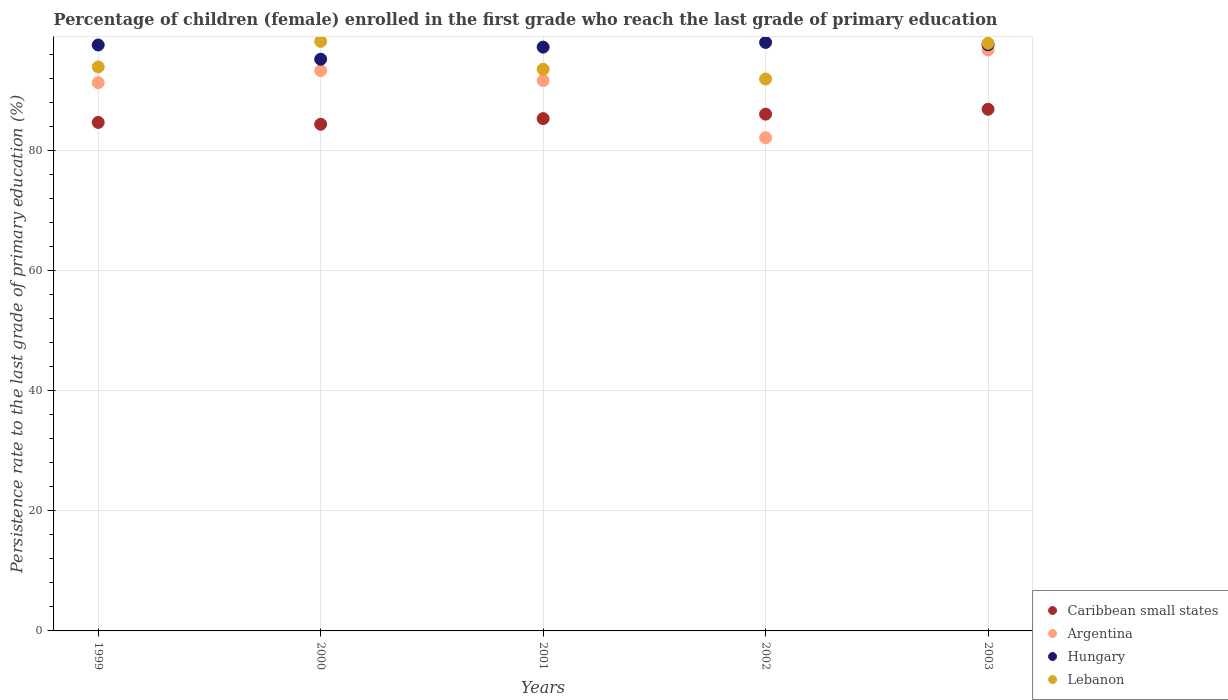Is the number of dotlines equal to the number of legend labels?
Your answer should be compact. Yes. What is the persistence rate of children in Hungary in 2003?
Your answer should be compact. 97.58. Across all years, what is the maximum persistence rate of children in Lebanon?
Your response must be concise. 98.15. Across all years, what is the minimum persistence rate of children in Lebanon?
Make the answer very short. 91.89. In which year was the persistence rate of children in Caribbean small states maximum?
Make the answer very short. 2003. In which year was the persistence rate of children in Caribbean small states minimum?
Give a very brief answer. 2000. What is the total persistence rate of children in Argentina in the graph?
Provide a succinct answer. 455.02. What is the difference between the persistence rate of children in Caribbean small states in 1999 and that in 2000?
Your answer should be compact. 0.3. What is the difference between the persistence rate of children in Argentina in 2002 and the persistence rate of children in Lebanon in 1999?
Provide a short and direct response. -11.79. What is the average persistence rate of children in Argentina per year?
Your response must be concise. 91. In the year 2002, what is the difference between the persistence rate of children in Caribbean small states and persistence rate of children in Hungary?
Ensure brevity in your answer.  -11.94. In how many years, is the persistence rate of children in Argentina greater than 16 %?
Your answer should be compact. 5. What is the ratio of the persistence rate of children in Caribbean small states in 1999 to that in 2002?
Ensure brevity in your answer.  0.98. Is the difference between the persistence rate of children in Caribbean small states in 1999 and 2001 greater than the difference between the persistence rate of children in Hungary in 1999 and 2001?
Give a very brief answer. No. What is the difference between the highest and the second highest persistence rate of children in Argentina?
Your response must be concise. 3.44. What is the difference between the highest and the lowest persistence rate of children in Hungary?
Your answer should be compact. 2.8. Is it the case that in every year, the sum of the persistence rate of children in Caribbean small states and persistence rate of children in Hungary  is greater than the sum of persistence rate of children in Lebanon and persistence rate of children in Argentina?
Make the answer very short. No. Is the persistence rate of children in Hungary strictly greater than the persistence rate of children in Caribbean small states over the years?
Your response must be concise. Yes. How many dotlines are there?
Your answer should be compact. 4. How many years are there in the graph?
Your response must be concise. 5. What is the difference between two consecutive major ticks on the Y-axis?
Give a very brief answer. 20. Are the values on the major ticks of Y-axis written in scientific E-notation?
Offer a very short reply. No. Does the graph contain any zero values?
Provide a short and direct response. No. Where does the legend appear in the graph?
Make the answer very short. Bottom right. How many legend labels are there?
Offer a terse response. 4. How are the legend labels stacked?
Give a very brief answer. Vertical. What is the title of the graph?
Your response must be concise. Percentage of children (female) enrolled in the first grade who reach the last grade of primary education. What is the label or title of the Y-axis?
Your answer should be compact. Persistence rate to the last grade of primary education (%). What is the Persistence rate to the last grade of primary education (%) in Caribbean small states in 1999?
Provide a short and direct response. 84.66. What is the Persistence rate to the last grade of primary education (%) in Argentina in 1999?
Ensure brevity in your answer.  91.28. What is the Persistence rate to the last grade of primary education (%) of Hungary in 1999?
Provide a succinct answer. 97.55. What is the Persistence rate to the last grade of primary education (%) of Lebanon in 1999?
Provide a short and direct response. 93.9. What is the Persistence rate to the last grade of primary education (%) in Caribbean small states in 2000?
Give a very brief answer. 84.36. What is the Persistence rate to the last grade of primary education (%) in Argentina in 2000?
Make the answer very short. 93.28. What is the Persistence rate to the last grade of primary education (%) in Hungary in 2000?
Your answer should be very brief. 95.18. What is the Persistence rate to the last grade of primary education (%) of Lebanon in 2000?
Offer a terse response. 98.15. What is the Persistence rate to the last grade of primary education (%) of Caribbean small states in 2001?
Make the answer very short. 85.3. What is the Persistence rate to the last grade of primary education (%) in Argentina in 2001?
Your answer should be compact. 91.63. What is the Persistence rate to the last grade of primary education (%) of Hungary in 2001?
Your response must be concise. 97.19. What is the Persistence rate to the last grade of primary education (%) in Lebanon in 2001?
Keep it short and to the point. 93.51. What is the Persistence rate to the last grade of primary education (%) of Caribbean small states in 2002?
Provide a succinct answer. 86.04. What is the Persistence rate to the last grade of primary education (%) of Argentina in 2002?
Your answer should be very brief. 82.11. What is the Persistence rate to the last grade of primary education (%) of Hungary in 2002?
Offer a very short reply. 97.98. What is the Persistence rate to the last grade of primary education (%) of Lebanon in 2002?
Give a very brief answer. 91.89. What is the Persistence rate to the last grade of primary education (%) in Caribbean small states in 2003?
Your answer should be very brief. 86.85. What is the Persistence rate to the last grade of primary education (%) of Argentina in 2003?
Make the answer very short. 96.72. What is the Persistence rate to the last grade of primary education (%) of Hungary in 2003?
Provide a short and direct response. 97.58. What is the Persistence rate to the last grade of primary education (%) of Lebanon in 2003?
Your response must be concise. 97.84. Across all years, what is the maximum Persistence rate to the last grade of primary education (%) of Caribbean small states?
Give a very brief answer. 86.85. Across all years, what is the maximum Persistence rate to the last grade of primary education (%) in Argentina?
Ensure brevity in your answer.  96.72. Across all years, what is the maximum Persistence rate to the last grade of primary education (%) in Hungary?
Make the answer very short. 97.98. Across all years, what is the maximum Persistence rate to the last grade of primary education (%) in Lebanon?
Offer a terse response. 98.15. Across all years, what is the minimum Persistence rate to the last grade of primary education (%) in Caribbean small states?
Provide a short and direct response. 84.36. Across all years, what is the minimum Persistence rate to the last grade of primary education (%) in Argentina?
Offer a very short reply. 82.11. Across all years, what is the minimum Persistence rate to the last grade of primary education (%) of Hungary?
Provide a short and direct response. 95.18. Across all years, what is the minimum Persistence rate to the last grade of primary education (%) of Lebanon?
Your response must be concise. 91.89. What is the total Persistence rate to the last grade of primary education (%) in Caribbean small states in the graph?
Make the answer very short. 427.2. What is the total Persistence rate to the last grade of primary education (%) of Argentina in the graph?
Keep it short and to the point. 455.02. What is the total Persistence rate to the last grade of primary education (%) in Hungary in the graph?
Your response must be concise. 485.49. What is the total Persistence rate to the last grade of primary education (%) in Lebanon in the graph?
Ensure brevity in your answer.  475.29. What is the difference between the Persistence rate to the last grade of primary education (%) in Caribbean small states in 1999 and that in 2000?
Give a very brief answer. 0.3. What is the difference between the Persistence rate to the last grade of primary education (%) of Argentina in 1999 and that in 2000?
Provide a short and direct response. -2. What is the difference between the Persistence rate to the last grade of primary education (%) of Hungary in 1999 and that in 2000?
Give a very brief answer. 2.37. What is the difference between the Persistence rate to the last grade of primary education (%) of Lebanon in 1999 and that in 2000?
Keep it short and to the point. -4.25. What is the difference between the Persistence rate to the last grade of primary education (%) of Caribbean small states in 1999 and that in 2001?
Offer a very short reply. -0.64. What is the difference between the Persistence rate to the last grade of primary education (%) of Argentina in 1999 and that in 2001?
Give a very brief answer. -0.35. What is the difference between the Persistence rate to the last grade of primary education (%) of Hungary in 1999 and that in 2001?
Provide a succinct answer. 0.36. What is the difference between the Persistence rate to the last grade of primary education (%) of Lebanon in 1999 and that in 2001?
Make the answer very short. 0.39. What is the difference between the Persistence rate to the last grade of primary education (%) in Caribbean small states in 1999 and that in 2002?
Your answer should be very brief. -1.38. What is the difference between the Persistence rate to the last grade of primary education (%) in Argentina in 1999 and that in 2002?
Provide a succinct answer. 9.17. What is the difference between the Persistence rate to the last grade of primary education (%) of Hungary in 1999 and that in 2002?
Make the answer very short. -0.42. What is the difference between the Persistence rate to the last grade of primary education (%) of Lebanon in 1999 and that in 2002?
Make the answer very short. 2.01. What is the difference between the Persistence rate to the last grade of primary education (%) in Caribbean small states in 1999 and that in 2003?
Make the answer very short. -2.19. What is the difference between the Persistence rate to the last grade of primary education (%) of Argentina in 1999 and that in 2003?
Offer a terse response. -5.44. What is the difference between the Persistence rate to the last grade of primary education (%) in Hungary in 1999 and that in 2003?
Your answer should be very brief. -0.03. What is the difference between the Persistence rate to the last grade of primary education (%) in Lebanon in 1999 and that in 2003?
Offer a very short reply. -3.94. What is the difference between the Persistence rate to the last grade of primary education (%) of Caribbean small states in 2000 and that in 2001?
Provide a short and direct response. -0.94. What is the difference between the Persistence rate to the last grade of primary education (%) of Argentina in 2000 and that in 2001?
Your answer should be compact. 1.65. What is the difference between the Persistence rate to the last grade of primary education (%) of Hungary in 2000 and that in 2001?
Ensure brevity in your answer.  -2.01. What is the difference between the Persistence rate to the last grade of primary education (%) in Lebanon in 2000 and that in 2001?
Your answer should be compact. 4.64. What is the difference between the Persistence rate to the last grade of primary education (%) of Caribbean small states in 2000 and that in 2002?
Give a very brief answer. -1.68. What is the difference between the Persistence rate to the last grade of primary education (%) in Argentina in 2000 and that in 2002?
Your answer should be very brief. 11.17. What is the difference between the Persistence rate to the last grade of primary education (%) of Hungary in 2000 and that in 2002?
Keep it short and to the point. -2.8. What is the difference between the Persistence rate to the last grade of primary education (%) in Lebanon in 2000 and that in 2002?
Your response must be concise. 6.26. What is the difference between the Persistence rate to the last grade of primary education (%) of Caribbean small states in 2000 and that in 2003?
Ensure brevity in your answer.  -2.49. What is the difference between the Persistence rate to the last grade of primary education (%) of Argentina in 2000 and that in 2003?
Provide a short and direct response. -3.44. What is the difference between the Persistence rate to the last grade of primary education (%) in Hungary in 2000 and that in 2003?
Keep it short and to the point. -2.4. What is the difference between the Persistence rate to the last grade of primary education (%) in Lebanon in 2000 and that in 2003?
Provide a succinct answer. 0.32. What is the difference between the Persistence rate to the last grade of primary education (%) in Caribbean small states in 2001 and that in 2002?
Ensure brevity in your answer.  -0.74. What is the difference between the Persistence rate to the last grade of primary education (%) in Argentina in 2001 and that in 2002?
Your answer should be very brief. 9.52. What is the difference between the Persistence rate to the last grade of primary education (%) of Hungary in 2001 and that in 2002?
Your answer should be very brief. -0.78. What is the difference between the Persistence rate to the last grade of primary education (%) in Lebanon in 2001 and that in 2002?
Keep it short and to the point. 1.62. What is the difference between the Persistence rate to the last grade of primary education (%) in Caribbean small states in 2001 and that in 2003?
Provide a succinct answer. -1.55. What is the difference between the Persistence rate to the last grade of primary education (%) of Argentina in 2001 and that in 2003?
Ensure brevity in your answer.  -5.09. What is the difference between the Persistence rate to the last grade of primary education (%) of Hungary in 2001 and that in 2003?
Give a very brief answer. -0.39. What is the difference between the Persistence rate to the last grade of primary education (%) in Lebanon in 2001 and that in 2003?
Provide a succinct answer. -4.33. What is the difference between the Persistence rate to the last grade of primary education (%) in Caribbean small states in 2002 and that in 2003?
Provide a short and direct response. -0.81. What is the difference between the Persistence rate to the last grade of primary education (%) of Argentina in 2002 and that in 2003?
Your answer should be compact. -14.61. What is the difference between the Persistence rate to the last grade of primary education (%) of Hungary in 2002 and that in 2003?
Give a very brief answer. 0.4. What is the difference between the Persistence rate to the last grade of primary education (%) of Lebanon in 2002 and that in 2003?
Give a very brief answer. -5.95. What is the difference between the Persistence rate to the last grade of primary education (%) in Caribbean small states in 1999 and the Persistence rate to the last grade of primary education (%) in Argentina in 2000?
Your response must be concise. -8.62. What is the difference between the Persistence rate to the last grade of primary education (%) of Caribbean small states in 1999 and the Persistence rate to the last grade of primary education (%) of Hungary in 2000?
Give a very brief answer. -10.52. What is the difference between the Persistence rate to the last grade of primary education (%) of Caribbean small states in 1999 and the Persistence rate to the last grade of primary education (%) of Lebanon in 2000?
Provide a short and direct response. -13.49. What is the difference between the Persistence rate to the last grade of primary education (%) of Argentina in 1999 and the Persistence rate to the last grade of primary education (%) of Hungary in 2000?
Offer a terse response. -3.9. What is the difference between the Persistence rate to the last grade of primary education (%) in Argentina in 1999 and the Persistence rate to the last grade of primary education (%) in Lebanon in 2000?
Make the answer very short. -6.87. What is the difference between the Persistence rate to the last grade of primary education (%) of Hungary in 1999 and the Persistence rate to the last grade of primary education (%) of Lebanon in 2000?
Ensure brevity in your answer.  -0.6. What is the difference between the Persistence rate to the last grade of primary education (%) in Caribbean small states in 1999 and the Persistence rate to the last grade of primary education (%) in Argentina in 2001?
Give a very brief answer. -6.97. What is the difference between the Persistence rate to the last grade of primary education (%) in Caribbean small states in 1999 and the Persistence rate to the last grade of primary education (%) in Hungary in 2001?
Ensure brevity in your answer.  -12.53. What is the difference between the Persistence rate to the last grade of primary education (%) in Caribbean small states in 1999 and the Persistence rate to the last grade of primary education (%) in Lebanon in 2001?
Provide a short and direct response. -8.85. What is the difference between the Persistence rate to the last grade of primary education (%) in Argentina in 1999 and the Persistence rate to the last grade of primary education (%) in Hungary in 2001?
Ensure brevity in your answer.  -5.92. What is the difference between the Persistence rate to the last grade of primary education (%) of Argentina in 1999 and the Persistence rate to the last grade of primary education (%) of Lebanon in 2001?
Ensure brevity in your answer.  -2.23. What is the difference between the Persistence rate to the last grade of primary education (%) in Hungary in 1999 and the Persistence rate to the last grade of primary education (%) in Lebanon in 2001?
Your response must be concise. 4.05. What is the difference between the Persistence rate to the last grade of primary education (%) in Caribbean small states in 1999 and the Persistence rate to the last grade of primary education (%) in Argentina in 2002?
Your answer should be compact. 2.55. What is the difference between the Persistence rate to the last grade of primary education (%) in Caribbean small states in 1999 and the Persistence rate to the last grade of primary education (%) in Hungary in 2002?
Offer a terse response. -13.32. What is the difference between the Persistence rate to the last grade of primary education (%) of Caribbean small states in 1999 and the Persistence rate to the last grade of primary education (%) of Lebanon in 2002?
Ensure brevity in your answer.  -7.23. What is the difference between the Persistence rate to the last grade of primary education (%) in Argentina in 1999 and the Persistence rate to the last grade of primary education (%) in Hungary in 2002?
Ensure brevity in your answer.  -6.7. What is the difference between the Persistence rate to the last grade of primary education (%) of Argentina in 1999 and the Persistence rate to the last grade of primary education (%) of Lebanon in 2002?
Offer a very short reply. -0.61. What is the difference between the Persistence rate to the last grade of primary education (%) in Hungary in 1999 and the Persistence rate to the last grade of primary education (%) in Lebanon in 2002?
Make the answer very short. 5.66. What is the difference between the Persistence rate to the last grade of primary education (%) of Caribbean small states in 1999 and the Persistence rate to the last grade of primary education (%) of Argentina in 2003?
Offer a terse response. -12.06. What is the difference between the Persistence rate to the last grade of primary education (%) in Caribbean small states in 1999 and the Persistence rate to the last grade of primary education (%) in Hungary in 2003?
Your response must be concise. -12.92. What is the difference between the Persistence rate to the last grade of primary education (%) in Caribbean small states in 1999 and the Persistence rate to the last grade of primary education (%) in Lebanon in 2003?
Keep it short and to the point. -13.18. What is the difference between the Persistence rate to the last grade of primary education (%) of Argentina in 1999 and the Persistence rate to the last grade of primary education (%) of Hungary in 2003?
Provide a succinct answer. -6.3. What is the difference between the Persistence rate to the last grade of primary education (%) of Argentina in 1999 and the Persistence rate to the last grade of primary education (%) of Lebanon in 2003?
Keep it short and to the point. -6.56. What is the difference between the Persistence rate to the last grade of primary education (%) of Hungary in 1999 and the Persistence rate to the last grade of primary education (%) of Lebanon in 2003?
Keep it short and to the point. -0.28. What is the difference between the Persistence rate to the last grade of primary education (%) of Caribbean small states in 2000 and the Persistence rate to the last grade of primary education (%) of Argentina in 2001?
Offer a terse response. -7.27. What is the difference between the Persistence rate to the last grade of primary education (%) of Caribbean small states in 2000 and the Persistence rate to the last grade of primary education (%) of Hungary in 2001?
Your answer should be very brief. -12.84. What is the difference between the Persistence rate to the last grade of primary education (%) of Caribbean small states in 2000 and the Persistence rate to the last grade of primary education (%) of Lebanon in 2001?
Ensure brevity in your answer.  -9.15. What is the difference between the Persistence rate to the last grade of primary education (%) of Argentina in 2000 and the Persistence rate to the last grade of primary education (%) of Hungary in 2001?
Offer a terse response. -3.91. What is the difference between the Persistence rate to the last grade of primary education (%) in Argentina in 2000 and the Persistence rate to the last grade of primary education (%) in Lebanon in 2001?
Keep it short and to the point. -0.23. What is the difference between the Persistence rate to the last grade of primary education (%) in Hungary in 2000 and the Persistence rate to the last grade of primary education (%) in Lebanon in 2001?
Provide a succinct answer. 1.67. What is the difference between the Persistence rate to the last grade of primary education (%) of Caribbean small states in 2000 and the Persistence rate to the last grade of primary education (%) of Argentina in 2002?
Give a very brief answer. 2.25. What is the difference between the Persistence rate to the last grade of primary education (%) in Caribbean small states in 2000 and the Persistence rate to the last grade of primary education (%) in Hungary in 2002?
Offer a terse response. -13.62. What is the difference between the Persistence rate to the last grade of primary education (%) in Caribbean small states in 2000 and the Persistence rate to the last grade of primary education (%) in Lebanon in 2002?
Ensure brevity in your answer.  -7.54. What is the difference between the Persistence rate to the last grade of primary education (%) in Argentina in 2000 and the Persistence rate to the last grade of primary education (%) in Hungary in 2002?
Offer a terse response. -4.69. What is the difference between the Persistence rate to the last grade of primary education (%) of Argentina in 2000 and the Persistence rate to the last grade of primary education (%) of Lebanon in 2002?
Your answer should be very brief. 1.39. What is the difference between the Persistence rate to the last grade of primary education (%) in Hungary in 2000 and the Persistence rate to the last grade of primary education (%) in Lebanon in 2002?
Provide a short and direct response. 3.29. What is the difference between the Persistence rate to the last grade of primary education (%) in Caribbean small states in 2000 and the Persistence rate to the last grade of primary education (%) in Argentina in 2003?
Provide a short and direct response. -12.37. What is the difference between the Persistence rate to the last grade of primary education (%) of Caribbean small states in 2000 and the Persistence rate to the last grade of primary education (%) of Hungary in 2003?
Keep it short and to the point. -13.22. What is the difference between the Persistence rate to the last grade of primary education (%) of Caribbean small states in 2000 and the Persistence rate to the last grade of primary education (%) of Lebanon in 2003?
Ensure brevity in your answer.  -13.48. What is the difference between the Persistence rate to the last grade of primary education (%) in Argentina in 2000 and the Persistence rate to the last grade of primary education (%) in Hungary in 2003?
Your answer should be very brief. -4.3. What is the difference between the Persistence rate to the last grade of primary education (%) in Argentina in 2000 and the Persistence rate to the last grade of primary education (%) in Lebanon in 2003?
Provide a short and direct response. -4.55. What is the difference between the Persistence rate to the last grade of primary education (%) in Hungary in 2000 and the Persistence rate to the last grade of primary education (%) in Lebanon in 2003?
Offer a very short reply. -2.66. What is the difference between the Persistence rate to the last grade of primary education (%) in Caribbean small states in 2001 and the Persistence rate to the last grade of primary education (%) in Argentina in 2002?
Keep it short and to the point. 3.19. What is the difference between the Persistence rate to the last grade of primary education (%) of Caribbean small states in 2001 and the Persistence rate to the last grade of primary education (%) of Hungary in 2002?
Offer a very short reply. -12.68. What is the difference between the Persistence rate to the last grade of primary education (%) in Caribbean small states in 2001 and the Persistence rate to the last grade of primary education (%) in Lebanon in 2002?
Provide a short and direct response. -6.6. What is the difference between the Persistence rate to the last grade of primary education (%) in Argentina in 2001 and the Persistence rate to the last grade of primary education (%) in Hungary in 2002?
Your answer should be very brief. -6.35. What is the difference between the Persistence rate to the last grade of primary education (%) in Argentina in 2001 and the Persistence rate to the last grade of primary education (%) in Lebanon in 2002?
Ensure brevity in your answer.  -0.26. What is the difference between the Persistence rate to the last grade of primary education (%) of Hungary in 2001 and the Persistence rate to the last grade of primary education (%) of Lebanon in 2002?
Provide a succinct answer. 5.3. What is the difference between the Persistence rate to the last grade of primary education (%) of Caribbean small states in 2001 and the Persistence rate to the last grade of primary education (%) of Argentina in 2003?
Make the answer very short. -11.43. What is the difference between the Persistence rate to the last grade of primary education (%) of Caribbean small states in 2001 and the Persistence rate to the last grade of primary education (%) of Hungary in 2003?
Your response must be concise. -12.28. What is the difference between the Persistence rate to the last grade of primary education (%) in Caribbean small states in 2001 and the Persistence rate to the last grade of primary education (%) in Lebanon in 2003?
Your response must be concise. -12.54. What is the difference between the Persistence rate to the last grade of primary education (%) in Argentina in 2001 and the Persistence rate to the last grade of primary education (%) in Hungary in 2003?
Ensure brevity in your answer.  -5.95. What is the difference between the Persistence rate to the last grade of primary education (%) in Argentina in 2001 and the Persistence rate to the last grade of primary education (%) in Lebanon in 2003?
Your response must be concise. -6.21. What is the difference between the Persistence rate to the last grade of primary education (%) in Hungary in 2001 and the Persistence rate to the last grade of primary education (%) in Lebanon in 2003?
Provide a succinct answer. -0.64. What is the difference between the Persistence rate to the last grade of primary education (%) in Caribbean small states in 2002 and the Persistence rate to the last grade of primary education (%) in Argentina in 2003?
Your answer should be compact. -10.68. What is the difference between the Persistence rate to the last grade of primary education (%) of Caribbean small states in 2002 and the Persistence rate to the last grade of primary education (%) of Hungary in 2003?
Offer a very short reply. -11.54. What is the difference between the Persistence rate to the last grade of primary education (%) in Caribbean small states in 2002 and the Persistence rate to the last grade of primary education (%) in Lebanon in 2003?
Keep it short and to the point. -11.8. What is the difference between the Persistence rate to the last grade of primary education (%) of Argentina in 2002 and the Persistence rate to the last grade of primary education (%) of Hungary in 2003?
Offer a terse response. -15.47. What is the difference between the Persistence rate to the last grade of primary education (%) of Argentina in 2002 and the Persistence rate to the last grade of primary education (%) of Lebanon in 2003?
Provide a short and direct response. -15.73. What is the difference between the Persistence rate to the last grade of primary education (%) in Hungary in 2002 and the Persistence rate to the last grade of primary education (%) in Lebanon in 2003?
Your response must be concise. 0.14. What is the average Persistence rate to the last grade of primary education (%) of Caribbean small states per year?
Offer a terse response. 85.44. What is the average Persistence rate to the last grade of primary education (%) of Argentina per year?
Give a very brief answer. 91. What is the average Persistence rate to the last grade of primary education (%) in Hungary per year?
Offer a terse response. 97.1. What is the average Persistence rate to the last grade of primary education (%) of Lebanon per year?
Make the answer very short. 95.06. In the year 1999, what is the difference between the Persistence rate to the last grade of primary education (%) in Caribbean small states and Persistence rate to the last grade of primary education (%) in Argentina?
Keep it short and to the point. -6.62. In the year 1999, what is the difference between the Persistence rate to the last grade of primary education (%) of Caribbean small states and Persistence rate to the last grade of primary education (%) of Hungary?
Ensure brevity in your answer.  -12.89. In the year 1999, what is the difference between the Persistence rate to the last grade of primary education (%) in Caribbean small states and Persistence rate to the last grade of primary education (%) in Lebanon?
Provide a succinct answer. -9.24. In the year 1999, what is the difference between the Persistence rate to the last grade of primary education (%) in Argentina and Persistence rate to the last grade of primary education (%) in Hungary?
Offer a terse response. -6.28. In the year 1999, what is the difference between the Persistence rate to the last grade of primary education (%) in Argentina and Persistence rate to the last grade of primary education (%) in Lebanon?
Offer a terse response. -2.62. In the year 1999, what is the difference between the Persistence rate to the last grade of primary education (%) in Hungary and Persistence rate to the last grade of primary education (%) in Lebanon?
Your answer should be very brief. 3.66. In the year 2000, what is the difference between the Persistence rate to the last grade of primary education (%) in Caribbean small states and Persistence rate to the last grade of primary education (%) in Argentina?
Make the answer very short. -8.93. In the year 2000, what is the difference between the Persistence rate to the last grade of primary education (%) in Caribbean small states and Persistence rate to the last grade of primary education (%) in Hungary?
Offer a terse response. -10.83. In the year 2000, what is the difference between the Persistence rate to the last grade of primary education (%) of Caribbean small states and Persistence rate to the last grade of primary education (%) of Lebanon?
Your response must be concise. -13.8. In the year 2000, what is the difference between the Persistence rate to the last grade of primary education (%) of Argentina and Persistence rate to the last grade of primary education (%) of Hungary?
Give a very brief answer. -1.9. In the year 2000, what is the difference between the Persistence rate to the last grade of primary education (%) in Argentina and Persistence rate to the last grade of primary education (%) in Lebanon?
Provide a short and direct response. -4.87. In the year 2000, what is the difference between the Persistence rate to the last grade of primary education (%) in Hungary and Persistence rate to the last grade of primary education (%) in Lebanon?
Keep it short and to the point. -2.97. In the year 2001, what is the difference between the Persistence rate to the last grade of primary education (%) of Caribbean small states and Persistence rate to the last grade of primary education (%) of Argentina?
Your answer should be very brief. -6.33. In the year 2001, what is the difference between the Persistence rate to the last grade of primary education (%) in Caribbean small states and Persistence rate to the last grade of primary education (%) in Hungary?
Ensure brevity in your answer.  -11.9. In the year 2001, what is the difference between the Persistence rate to the last grade of primary education (%) of Caribbean small states and Persistence rate to the last grade of primary education (%) of Lebanon?
Give a very brief answer. -8.21. In the year 2001, what is the difference between the Persistence rate to the last grade of primary education (%) of Argentina and Persistence rate to the last grade of primary education (%) of Hungary?
Your answer should be very brief. -5.57. In the year 2001, what is the difference between the Persistence rate to the last grade of primary education (%) of Argentina and Persistence rate to the last grade of primary education (%) of Lebanon?
Ensure brevity in your answer.  -1.88. In the year 2001, what is the difference between the Persistence rate to the last grade of primary education (%) of Hungary and Persistence rate to the last grade of primary education (%) of Lebanon?
Offer a terse response. 3.69. In the year 2002, what is the difference between the Persistence rate to the last grade of primary education (%) in Caribbean small states and Persistence rate to the last grade of primary education (%) in Argentina?
Your response must be concise. 3.93. In the year 2002, what is the difference between the Persistence rate to the last grade of primary education (%) in Caribbean small states and Persistence rate to the last grade of primary education (%) in Hungary?
Offer a terse response. -11.94. In the year 2002, what is the difference between the Persistence rate to the last grade of primary education (%) in Caribbean small states and Persistence rate to the last grade of primary education (%) in Lebanon?
Give a very brief answer. -5.85. In the year 2002, what is the difference between the Persistence rate to the last grade of primary education (%) of Argentina and Persistence rate to the last grade of primary education (%) of Hungary?
Ensure brevity in your answer.  -15.87. In the year 2002, what is the difference between the Persistence rate to the last grade of primary education (%) of Argentina and Persistence rate to the last grade of primary education (%) of Lebanon?
Your response must be concise. -9.78. In the year 2002, what is the difference between the Persistence rate to the last grade of primary education (%) in Hungary and Persistence rate to the last grade of primary education (%) in Lebanon?
Provide a succinct answer. 6.09. In the year 2003, what is the difference between the Persistence rate to the last grade of primary education (%) in Caribbean small states and Persistence rate to the last grade of primary education (%) in Argentina?
Provide a short and direct response. -9.87. In the year 2003, what is the difference between the Persistence rate to the last grade of primary education (%) of Caribbean small states and Persistence rate to the last grade of primary education (%) of Hungary?
Provide a succinct answer. -10.73. In the year 2003, what is the difference between the Persistence rate to the last grade of primary education (%) in Caribbean small states and Persistence rate to the last grade of primary education (%) in Lebanon?
Make the answer very short. -10.99. In the year 2003, what is the difference between the Persistence rate to the last grade of primary education (%) of Argentina and Persistence rate to the last grade of primary education (%) of Hungary?
Your answer should be compact. -0.86. In the year 2003, what is the difference between the Persistence rate to the last grade of primary education (%) in Argentina and Persistence rate to the last grade of primary education (%) in Lebanon?
Your answer should be very brief. -1.11. In the year 2003, what is the difference between the Persistence rate to the last grade of primary education (%) of Hungary and Persistence rate to the last grade of primary education (%) of Lebanon?
Offer a terse response. -0.26. What is the ratio of the Persistence rate to the last grade of primary education (%) in Caribbean small states in 1999 to that in 2000?
Your answer should be compact. 1. What is the ratio of the Persistence rate to the last grade of primary education (%) of Argentina in 1999 to that in 2000?
Your answer should be very brief. 0.98. What is the ratio of the Persistence rate to the last grade of primary education (%) in Hungary in 1999 to that in 2000?
Provide a succinct answer. 1.02. What is the ratio of the Persistence rate to the last grade of primary education (%) of Lebanon in 1999 to that in 2000?
Offer a very short reply. 0.96. What is the ratio of the Persistence rate to the last grade of primary education (%) of Argentina in 1999 to that in 2001?
Your answer should be very brief. 1. What is the ratio of the Persistence rate to the last grade of primary education (%) in Lebanon in 1999 to that in 2001?
Your answer should be very brief. 1. What is the ratio of the Persistence rate to the last grade of primary education (%) of Caribbean small states in 1999 to that in 2002?
Provide a succinct answer. 0.98. What is the ratio of the Persistence rate to the last grade of primary education (%) in Argentina in 1999 to that in 2002?
Your response must be concise. 1.11. What is the ratio of the Persistence rate to the last grade of primary education (%) of Lebanon in 1999 to that in 2002?
Offer a very short reply. 1.02. What is the ratio of the Persistence rate to the last grade of primary education (%) in Caribbean small states in 1999 to that in 2003?
Make the answer very short. 0.97. What is the ratio of the Persistence rate to the last grade of primary education (%) in Argentina in 1999 to that in 2003?
Provide a short and direct response. 0.94. What is the ratio of the Persistence rate to the last grade of primary education (%) of Lebanon in 1999 to that in 2003?
Your answer should be very brief. 0.96. What is the ratio of the Persistence rate to the last grade of primary education (%) of Caribbean small states in 2000 to that in 2001?
Your answer should be compact. 0.99. What is the ratio of the Persistence rate to the last grade of primary education (%) in Argentina in 2000 to that in 2001?
Provide a succinct answer. 1.02. What is the ratio of the Persistence rate to the last grade of primary education (%) of Hungary in 2000 to that in 2001?
Your answer should be very brief. 0.98. What is the ratio of the Persistence rate to the last grade of primary education (%) of Lebanon in 2000 to that in 2001?
Your answer should be compact. 1.05. What is the ratio of the Persistence rate to the last grade of primary education (%) in Caribbean small states in 2000 to that in 2002?
Offer a terse response. 0.98. What is the ratio of the Persistence rate to the last grade of primary education (%) of Argentina in 2000 to that in 2002?
Give a very brief answer. 1.14. What is the ratio of the Persistence rate to the last grade of primary education (%) in Hungary in 2000 to that in 2002?
Make the answer very short. 0.97. What is the ratio of the Persistence rate to the last grade of primary education (%) in Lebanon in 2000 to that in 2002?
Provide a short and direct response. 1.07. What is the ratio of the Persistence rate to the last grade of primary education (%) of Caribbean small states in 2000 to that in 2003?
Your answer should be very brief. 0.97. What is the ratio of the Persistence rate to the last grade of primary education (%) in Argentina in 2000 to that in 2003?
Make the answer very short. 0.96. What is the ratio of the Persistence rate to the last grade of primary education (%) of Hungary in 2000 to that in 2003?
Your answer should be very brief. 0.98. What is the ratio of the Persistence rate to the last grade of primary education (%) of Lebanon in 2000 to that in 2003?
Offer a very short reply. 1. What is the ratio of the Persistence rate to the last grade of primary education (%) in Argentina in 2001 to that in 2002?
Make the answer very short. 1.12. What is the ratio of the Persistence rate to the last grade of primary education (%) of Lebanon in 2001 to that in 2002?
Give a very brief answer. 1.02. What is the ratio of the Persistence rate to the last grade of primary education (%) of Caribbean small states in 2001 to that in 2003?
Keep it short and to the point. 0.98. What is the ratio of the Persistence rate to the last grade of primary education (%) in Argentina in 2001 to that in 2003?
Your answer should be compact. 0.95. What is the ratio of the Persistence rate to the last grade of primary education (%) in Hungary in 2001 to that in 2003?
Provide a short and direct response. 1. What is the ratio of the Persistence rate to the last grade of primary education (%) in Lebanon in 2001 to that in 2003?
Keep it short and to the point. 0.96. What is the ratio of the Persistence rate to the last grade of primary education (%) of Argentina in 2002 to that in 2003?
Keep it short and to the point. 0.85. What is the ratio of the Persistence rate to the last grade of primary education (%) of Hungary in 2002 to that in 2003?
Your response must be concise. 1. What is the ratio of the Persistence rate to the last grade of primary education (%) of Lebanon in 2002 to that in 2003?
Your answer should be very brief. 0.94. What is the difference between the highest and the second highest Persistence rate to the last grade of primary education (%) in Caribbean small states?
Keep it short and to the point. 0.81. What is the difference between the highest and the second highest Persistence rate to the last grade of primary education (%) in Argentina?
Offer a terse response. 3.44. What is the difference between the highest and the second highest Persistence rate to the last grade of primary education (%) of Hungary?
Make the answer very short. 0.4. What is the difference between the highest and the second highest Persistence rate to the last grade of primary education (%) in Lebanon?
Your answer should be very brief. 0.32. What is the difference between the highest and the lowest Persistence rate to the last grade of primary education (%) of Caribbean small states?
Keep it short and to the point. 2.49. What is the difference between the highest and the lowest Persistence rate to the last grade of primary education (%) in Argentina?
Ensure brevity in your answer.  14.61. What is the difference between the highest and the lowest Persistence rate to the last grade of primary education (%) of Hungary?
Make the answer very short. 2.8. What is the difference between the highest and the lowest Persistence rate to the last grade of primary education (%) of Lebanon?
Offer a terse response. 6.26. 